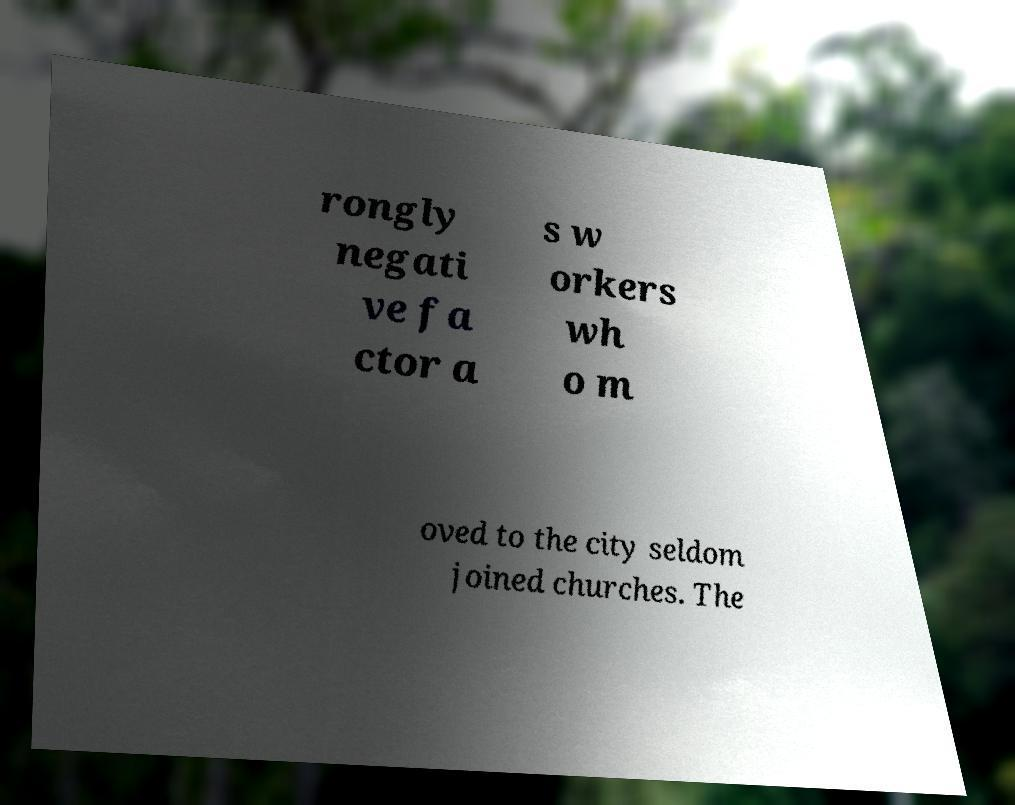Can you read and provide the text displayed in the image?This photo seems to have some interesting text. Can you extract and type it out for me? rongly negati ve fa ctor a s w orkers wh o m oved to the city seldom joined churches. The 